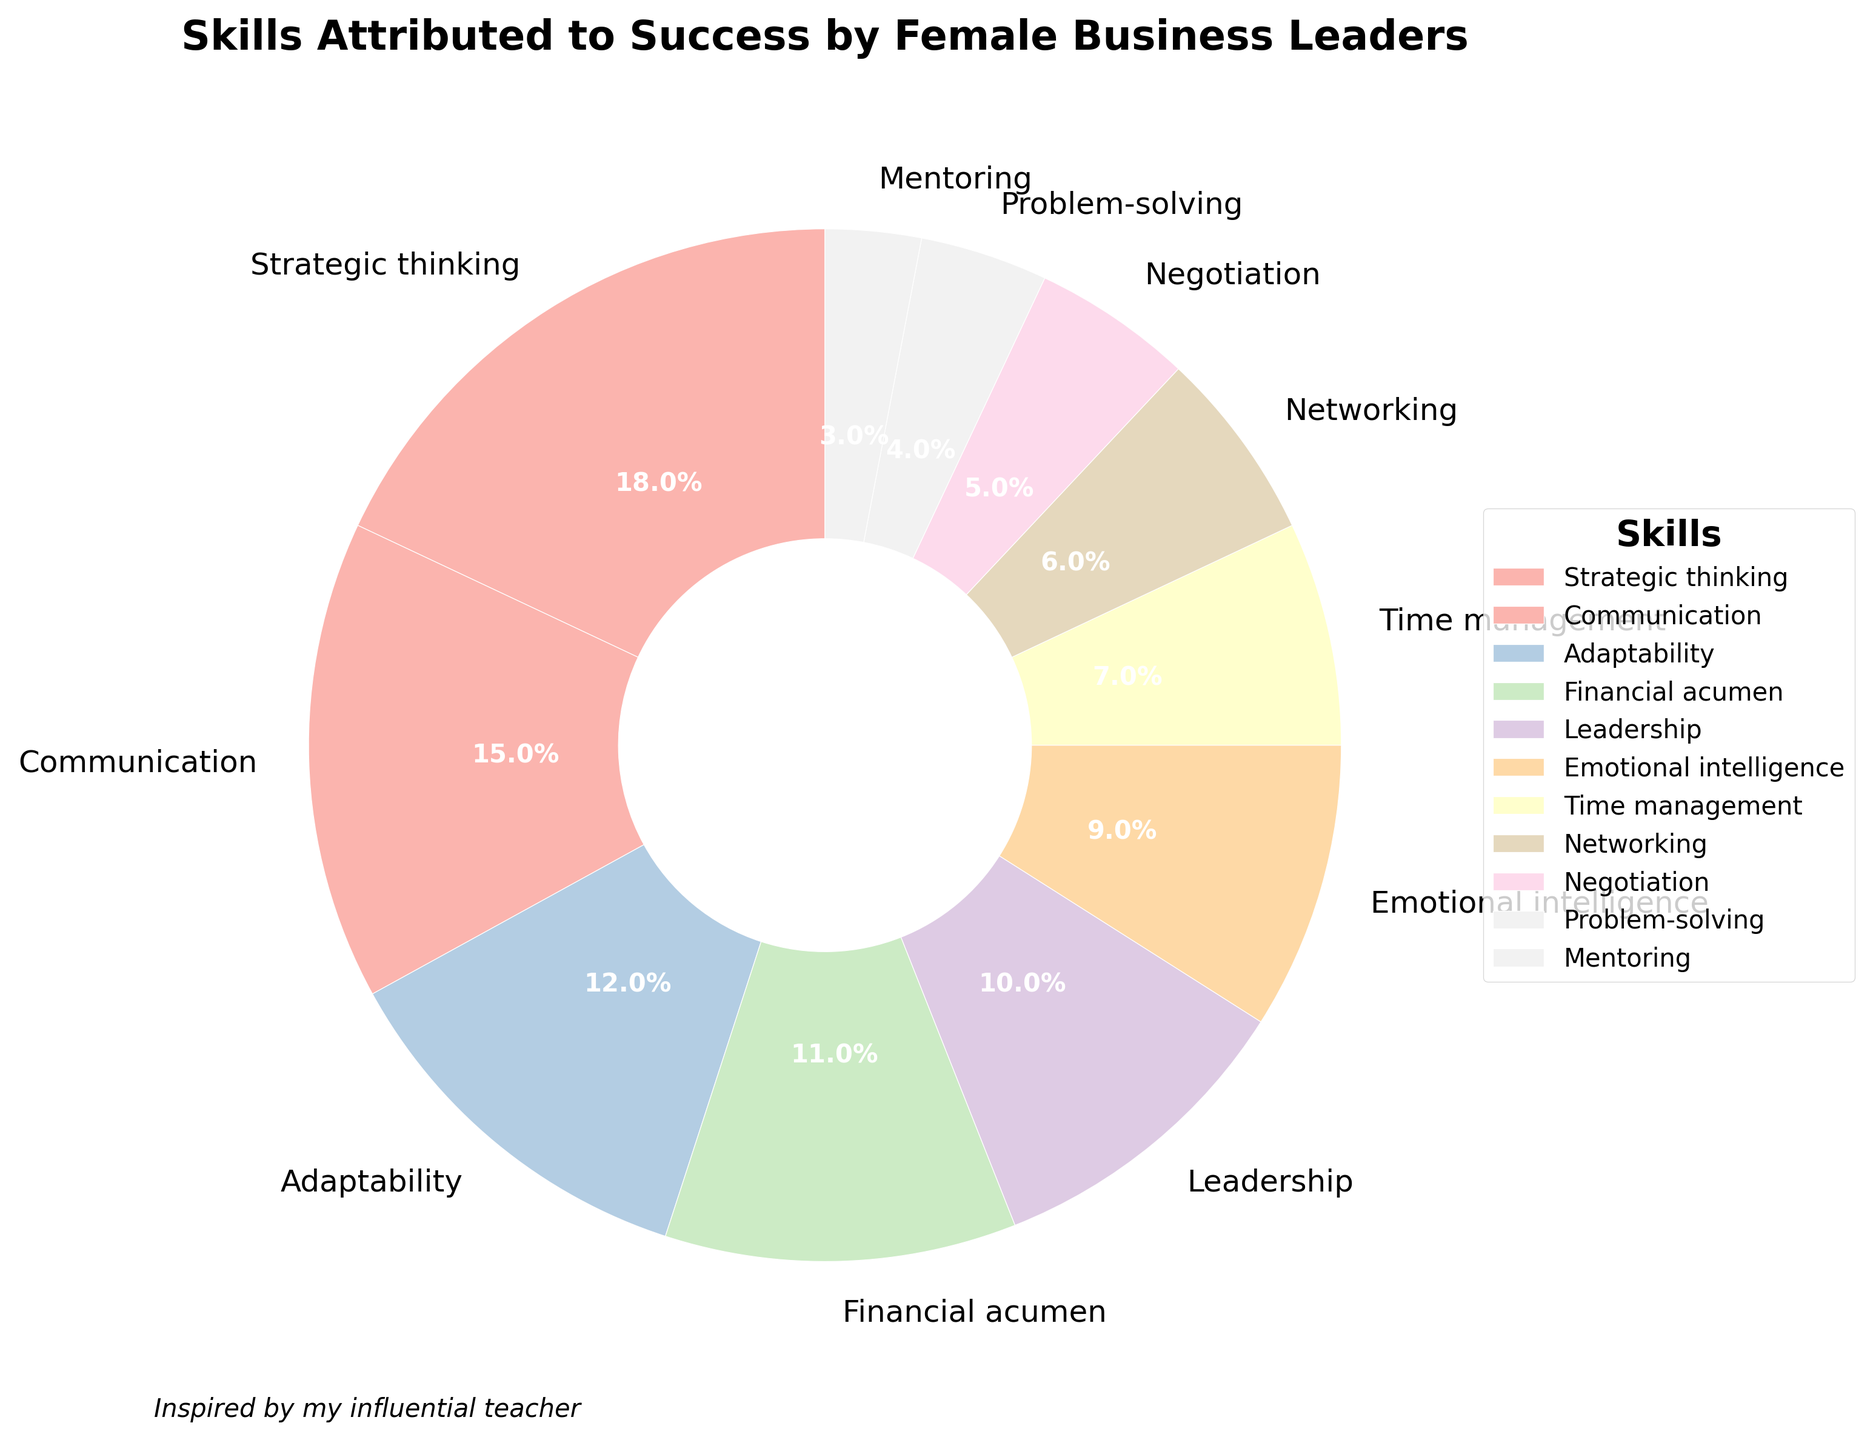What percentage of female business leaders attribute their success to Adaptability and Problem-solving combined? Add the percentages for Adaptability (12%) and Problem-solving (4%): 12 + 4 = 16.
Answer: 16% Which skill has the highest attribution by female business leaders? The skill with the largest slice in the chart is Strategic thinking, which has a percentage of 18%.
Answer: Strategic thinking Is the percentage of Networking attributed to success greater than that of Negotiation? Compare the percentages: Networking is 6% and Negotiation is 5%. Since 6% is greater than 5%, the answer is yes.
Answer: Yes What is the difference in percentage between Leadership and Emotional intelligence? Subtract the percentage of Emotional intelligence (9%) from Leadership (10%): 10 - 9 = 1.
Answer: 1 What are the two least attributed skills to success, and what are their combined percentages? The least attributed skills are Mentoring (3%) and Problem-solving (4%). Add these together, 3 + 4 = 7.
Answer: Mentoring and Problem-solving, 7% If you combine the percentages of skills learned from influential teachers, which total percentage is likely reflected in the chart (assuming Leadership, Communication, and Mentoring are taught by influential teachers)? Add the percentages for Leadership (10%), Communication (15%), and Mentoring (3%): 10 + 15 + 3 = 28.
Answer: 28% Does Time management have a lower percentage compared to Financial acumen? Compare the percentages: Time management is 7% and Financial acumen is 11%. Since 7% is less than 11%, the answer is yes.
Answer: Yes Which skills have a combined percentage greater than Financial acumen? For combined percentages greater than 11%, look at: 
- Adaptability (12%)
- Leadership (10%) + Emotional intelligence (9%) = 19%
- Communication (15%)
- Strategic thinking (18%)
So, the skills are Adaptability, Leadership + Emotional intelligence, Communication, and Strategic thinking.
Answer: Adaptability; Leadership + Emotional intelligence; Communication; Strategic thinking Among Emotional intelligence, Time management, and Negotiation, which skill has the lowest attribution, and what is its percentage? Compare the percentages: Emotional intelligence (9%), Time management (7%), and Negotiation (5%). The lowest is Negotiation with 5%.
Answer: Negotiation, 5% 